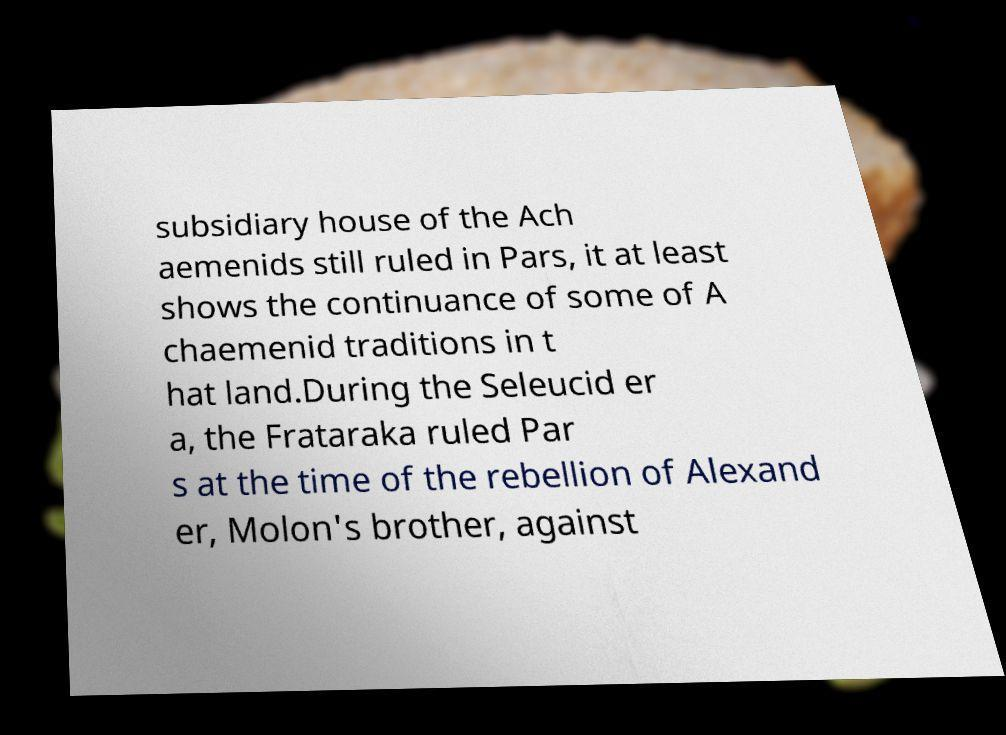What messages or text are displayed in this image? I need them in a readable, typed format. subsidiary house of the Ach aemenids still ruled in Pars, it at least shows the continuance of some of A chaemenid traditions in t hat land.During the Seleucid er a, the Frataraka ruled Par s at the time of the rebellion of Alexand er, Molon's brother, against 